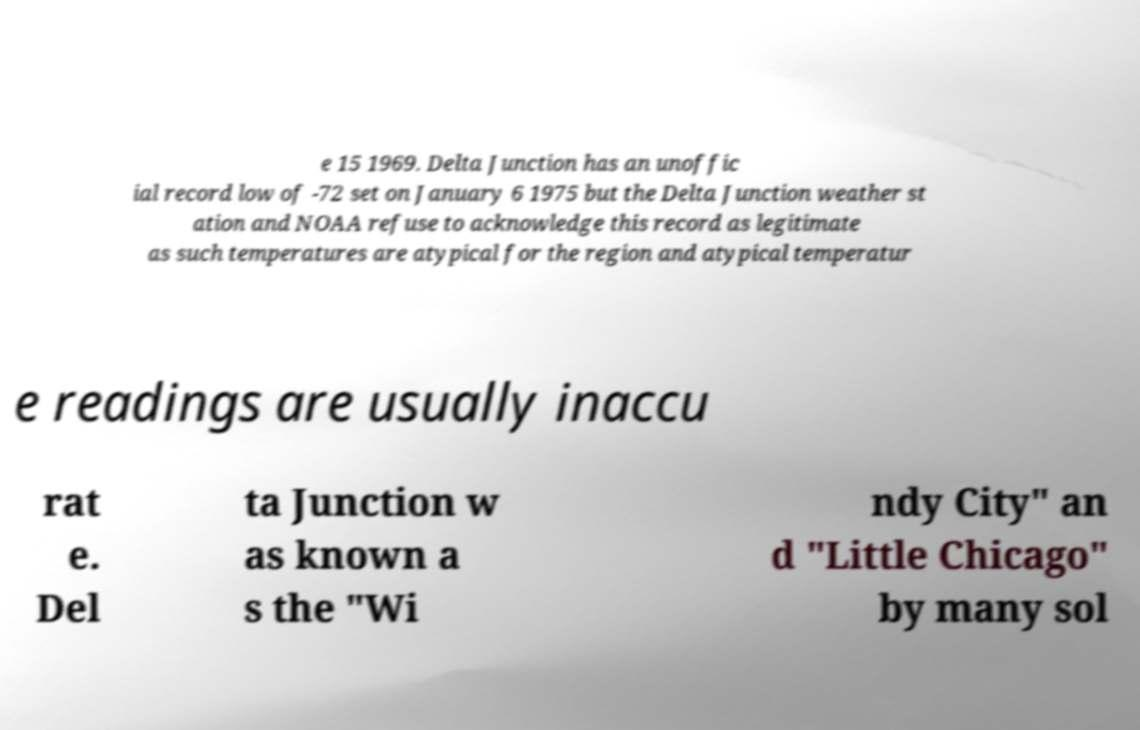Please read and relay the text visible in this image. What does it say? e 15 1969. Delta Junction has an unoffic ial record low of -72 set on January 6 1975 but the Delta Junction weather st ation and NOAA refuse to acknowledge this record as legitimate as such temperatures are atypical for the region and atypical temperatur e readings are usually inaccu rat e. Del ta Junction w as known a s the "Wi ndy City" an d "Little Chicago" by many sol 